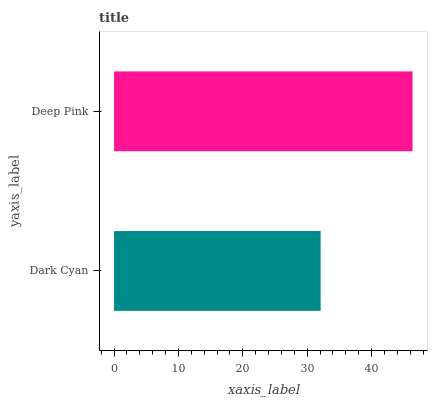Is Dark Cyan the minimum?
Answer yes or no. Yes. Is Deep Pink the maximum?
Answer yes or no. Yes. Is Deep Pink the minimum?
Answer yes or no. No. Is Deep Pink greater than Dark Cyan?
Answer yes or no. Yes. Is Dark Cyan less than Deep Pink?
Answer yes or no. Yes. Is Dark Cyan greater than Deep Pink?
Answer yes or no. No. Is Deep Pink less than Dark Cyan?
Answer yes or no. No. Is Deep Pink the high median?
Answer yes or no. Yes. Is Dark Cyan the low median?
Answer yes or no. Yes. Is Dark Cyan the high median?
Answer yes or no. No. Is Deep Pink the low median?
Answer yes or no. No. 